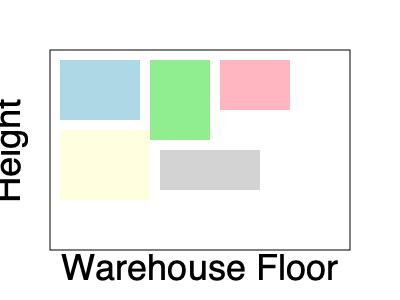As a logistics manager optimizing warehouse storage, you're implementing a 3D packing algorithm to minimize space usage. Given a set of rectangular boxes with dimensions (length, width, height) in feet: $\{(8,6,4), (6,5,8), (7,5,5), (9,7,3), (10,4,4)\}$, what is the minimum volume (in cubic feet) of a single container that can hold all these boxes, assuming they can be rotated but not overlapped? To solve this problem, we'll use a simple 3D bin packing heuristic:

1. Sort the boxes in descending order by volume:
   $$(6,5,8) = 240 \text{ ft}^3$$
   $$(8,6,4) = 192 \text{ ft}^3$$
   $$(9,7,3) = 189 \text{ ft}^3$$
   $$(7,5,5) = 175 \text{ ft}^3$$
   $$(10,4,4) = 160 \text{ ft}^3$$

2. Start with the largest box $(6,5,8)$ as the container base.

3. For each subsequent box, try to place it in the best-fitting orientation:
   - $(8,6,4)$ can be placed next to $(6,5,8)$, extending length to 14.
   - $(9,7,3)$ can be placed on top of $(8,6,4)$, extending height to 11.
   - $(7,5,5)$ can be placed next to $(6,5,8)$, extending width to 12.
   - $(10,4,4)$ can be placed on top of $(7,5,5)$, not changing dimensions.

4. The final container dimensions are $(14, 12, 11)$ feet.

5. Calculate the volume:
   $$V = 14 \times 12 \times 11 = 1,848 \text{ ft}^3$$

This is a heuristic solution and may not be the absolute minimum, but it provides a good estimate for the minimum container volume.
Answer: 1,848 cubic feet 